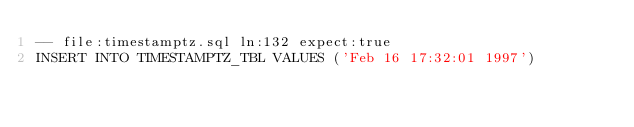Convert code to text. <code><loc_0><loc_0><loc_500><loc_500><_SQL_>-- file:timestamptz.sql ln:132 expect:true
INSERT INTO TIMESTAMPTZ_TBL VALUES ('Feb 16 17:32:01 1997')
</code> 